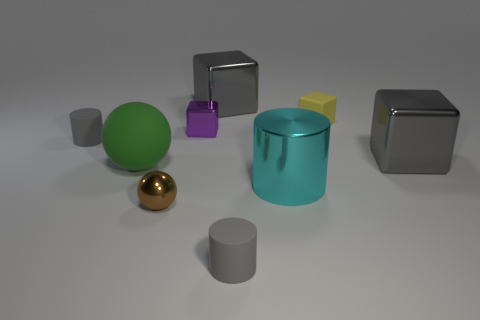Does the yellow thing have the same size as the purple cube?
Keep it short and to the point. Yes. Is there anything else that is the same shape as the large green matte object?
Ensure brevity in your answer.  Yes. Is the big cyan cylinder made of the same material as the ball that is behind the brown ball?
Offer a very short reply. No. Do the small matte cylinder that is in front of the green thing and the large metallic cylinder have the same color?
Give a very brief answer. No. How many metallic objects are on the right side of the small purple metallic cube and in front of the green sphere?
Ensure brevity in your answer.  1. What number of other objects are the same material as the small purple block?
Provide a succinct answer. 4. Does the large block behind the small yellow thing have the same material as the brown ball?
Offer a terse response. Yes. There is a gray rubber thing in front of the cylinder that is on the right side of the rubber thing in front of the tiny brown shiny thing; how big is it?
Offer a very short reply. Small. There is a brown metal thing that is the same size as the matte block; what is its shape?
Your response must be concise. Sphere. There is a gray shiny block that is to the left of the yellow block; what is its size?
Offer a terse response. Large. 